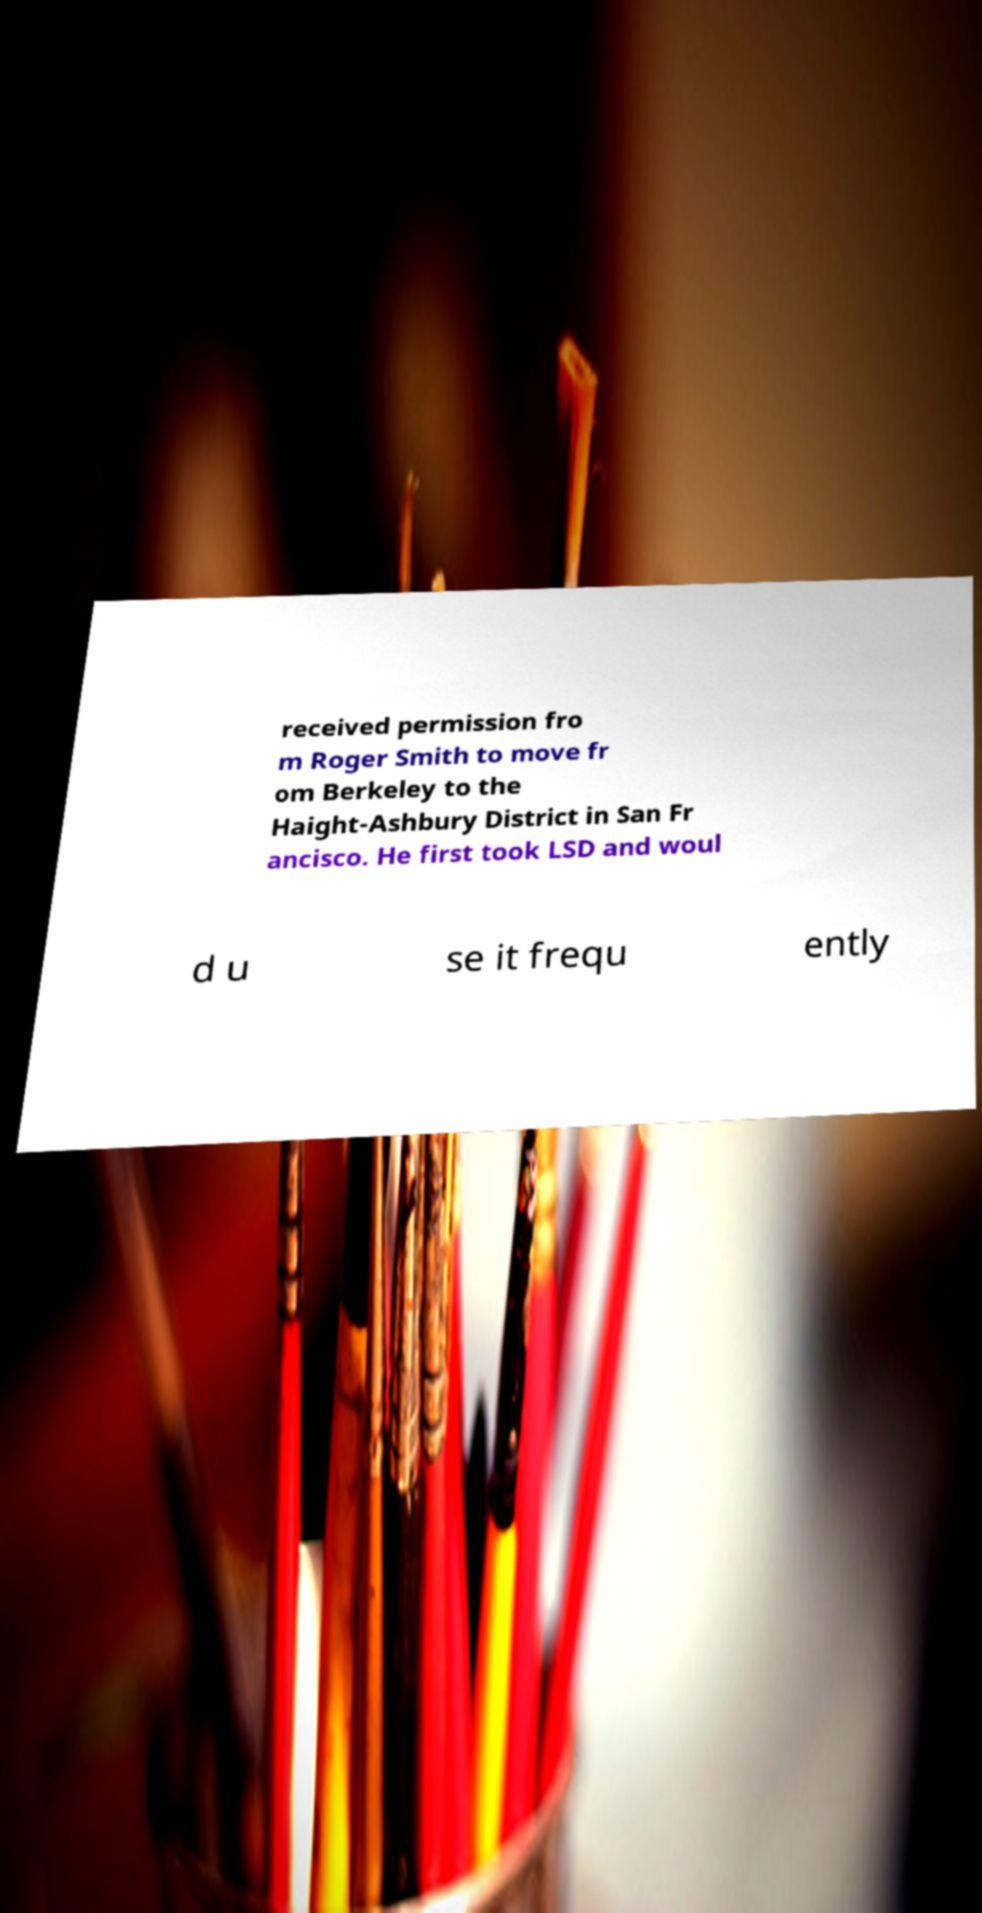Can you accurately transcribe the text from the provided image for me? received permission fro m Roger Smith to move fr om Berkeley to the Haight-Ashbury District in San Fr ancisco. He first took LSD and woul d u se it frequ ently 